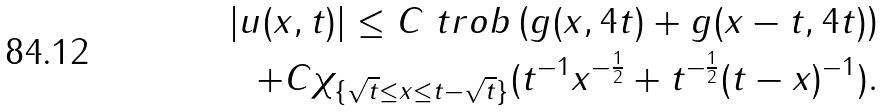<formula> <loc_0><loc_0><loc_500><loc_500>| u ( x , t ) | \leq C \ t r o b \left ( g ( x , 4 t ) + g ( x - t , 4 t ) \right ) \\ + C \chi _ { \{ \sqrt { t } \leq x \leq t - \sqrt { t } \} } ( t ^ { - 1 } x ^ { - \frac { 1 } { 2 } } + t ^ { - \frac { 1 } { 2 } } ( t - x ) ^ { - 1 } ) .</formula> 